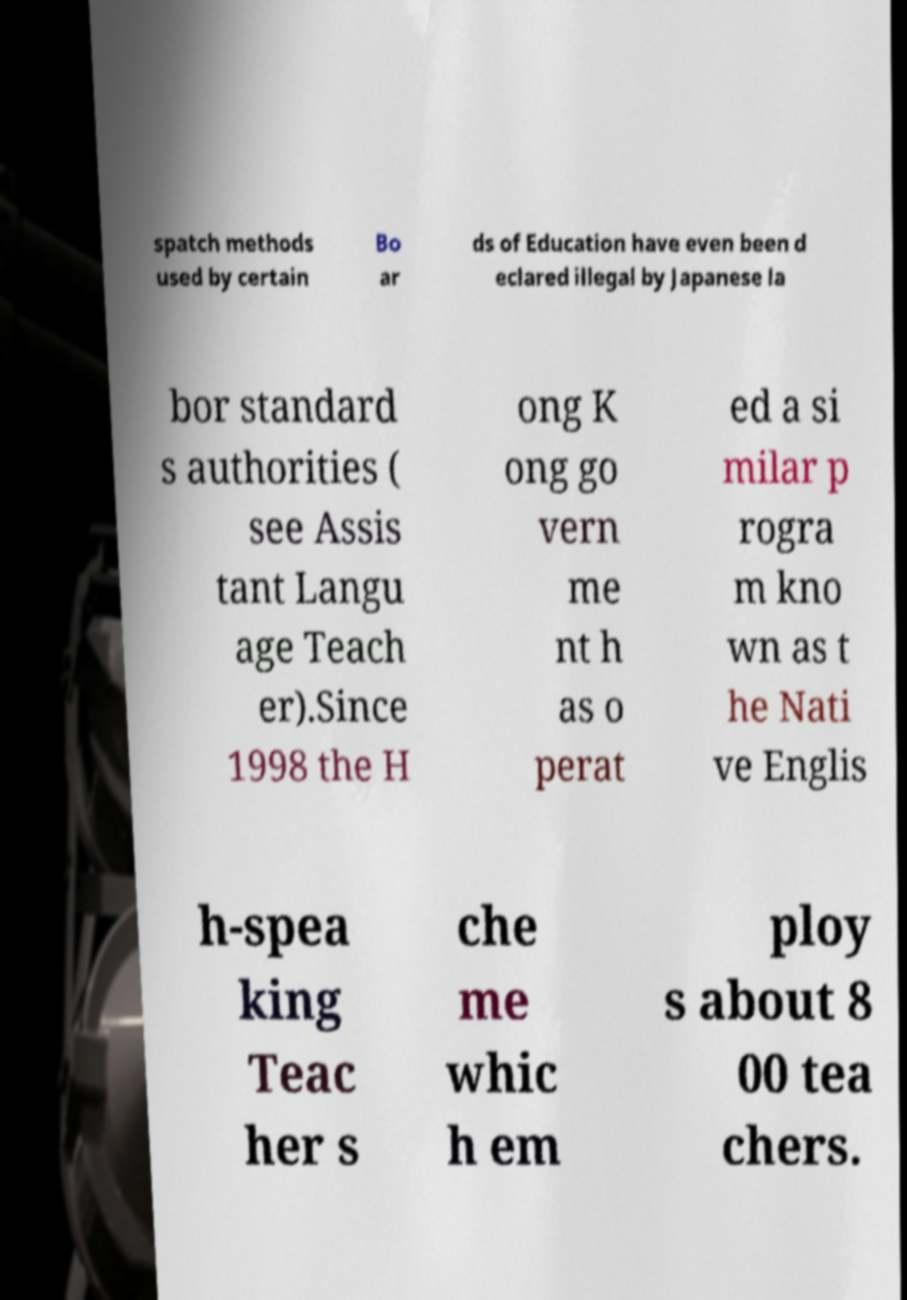Please identify and transcribe the text found in this image. spatch methods used by certain Bo ar ds of Education have even been d eclared illegal by Japanese la bor standard s authorities ( see Assis tant Langu age Teach er).Since 1998 the H ong K ong go vern me nt h as o perat ed a si milar p rogra m kno wn as t he Nati ve Englis h-spea king Teac her s che me whic h em ploy s about 8 00 tea chers. 